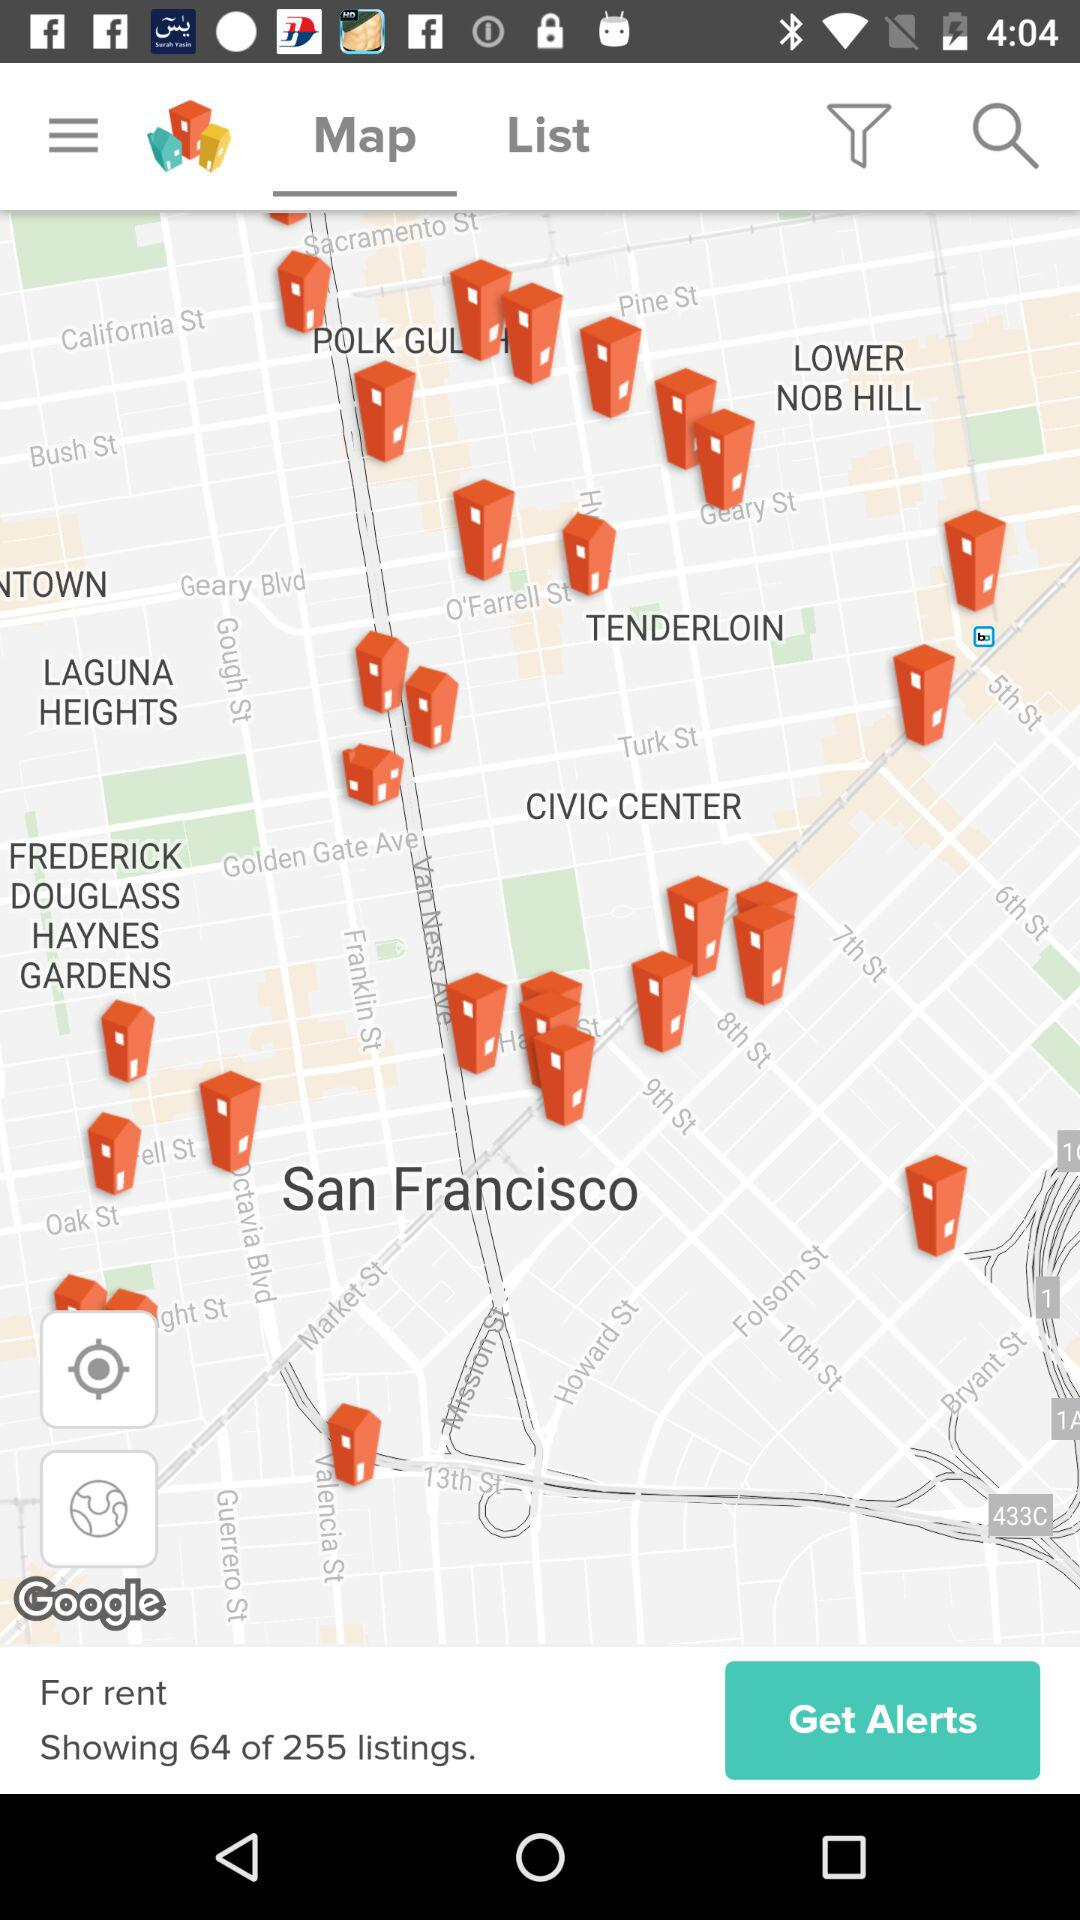Which tab am I using? You are using the "Map" tab. 